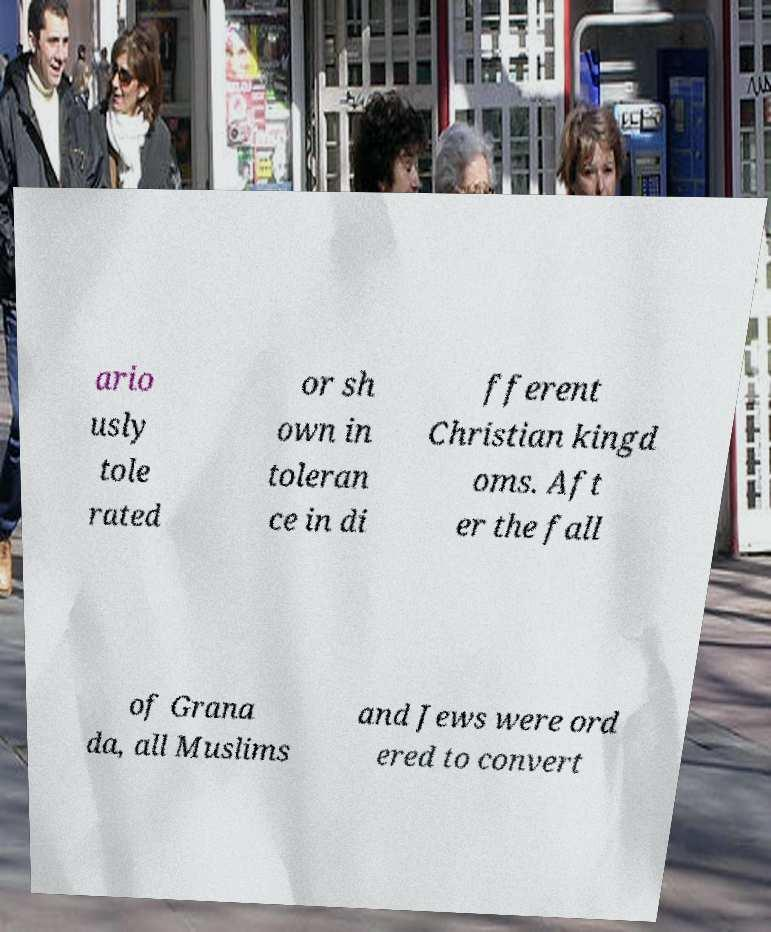Can you read and provide the text displayed in the image?This photo seems to have some interesting text. Can you extract and type it out for me? ario usly tole rated or sh own in toleran ce in di fferent Christian kingd oms. Aft er the fall of Grana da, all Muslims and Jews were ord ered to convert 